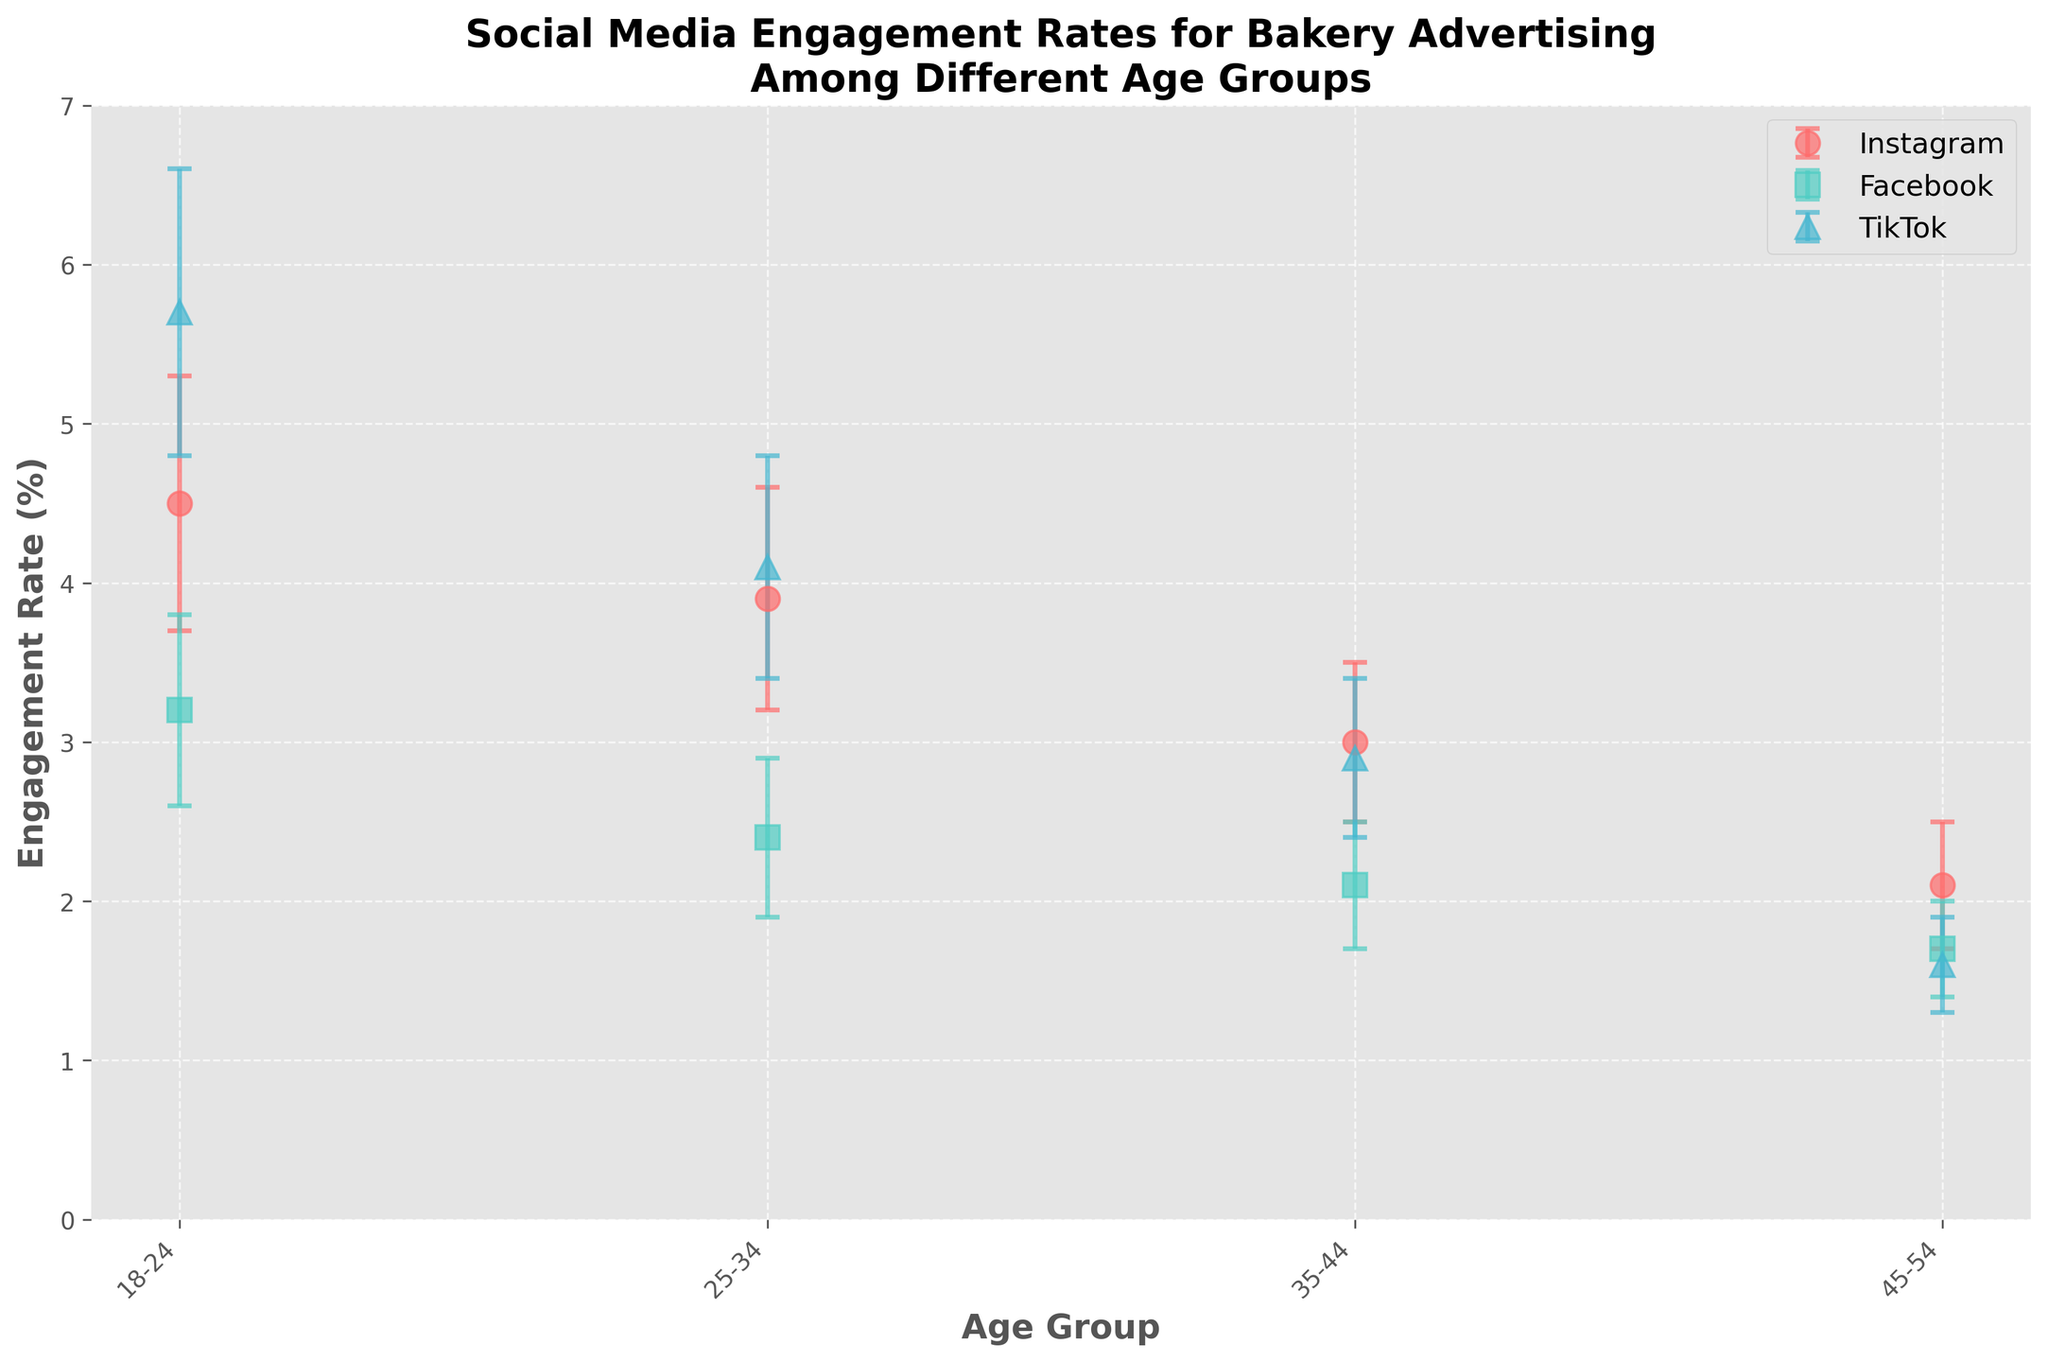What is the title of the figure? The title is displayed at the top of the figure and provides a summary of the visualized data.
Answer: Social Media Engagement Rates for Bakery Advertising Among Different Age Groups Which social media platform has the highest engagement rate for the 18-24 age group? The plot shows the engagement rates for each platform marked by different symbols. By locating the point with the highest value on the y-axis corresponding to the 18-24 age group, we see that TikTok has the highest engagement rate.
Answer: TikTok What is the engagement rate for Instagram in the 35-44 age group? The figure includes points representing engagement rates for different platforms and age groups. The point corresponding to Instagram (identified by a circular marker) in the 35-44 group on the x-axis shows the engagement rate.
Answer: 3.0% Which age group has the lowest engagement rate for TikTok? By examining the points corresponding to TikTok (identified by a triangular marker) across different age groups, the point with the lowest value on the y-axis is found in the 45-54 age group.
Answer: 45-54 Which two age groups have the same engagement rate for Facebook? By observing the points corresponding to Facebook (identified by a square marker) across different age groups, we see that the engagement rates for the 35-44 and 45-54 age groups are equal.
Answer: 35-44 and 45-54 How much higher is the engagement rate for TikTok in the 18-24 age group compared to Facebook in the same group? To determine this, we take the engagement rate for TikTok (5.7%) and subtract the engagement rate for Facebook (3.2%) in the 18-24 age group. The difference is 5.7 - 3.2.
Answer: 2.5% Which social media platform shows the most consistent engagement rates across different age groups based on error bars? The error bars indicate the uncertainty (or consistency) of the engagement rates. A smaller error bar denotes more consistency. By comparing the length of the error bars for all platforms across age groups, Facebook generally shows smaller error bars.
Answer: Facebook What is the overall trend in engagement rates with increasing age for Instagram? Observing the engagement points for Instagram across increasing age groups on the x-axis, the trend generally shows decreasing engagement rates as age increases.
Answer: Decreasing How do the engagement rates for Instagram and TikTok in the 25-34 age group compare? By comparing the points for Instagram and TikTok within the 25-34 age group, we see that TikTok has a higher engagement rate (4.1%) compared to Instagram (3.9%).
Answer: TikTok is higher What is the average engagement rate for TikTok across all age groups? To find the average, we sum all engagement rates for TikTok (5.7 + 4.1 + 2.9 + 1.6) and divide by the number of age groups (4). This gives (5.7 + 4.1 + 2.9 + 1.6) / 4.
Answer: 3.575% 